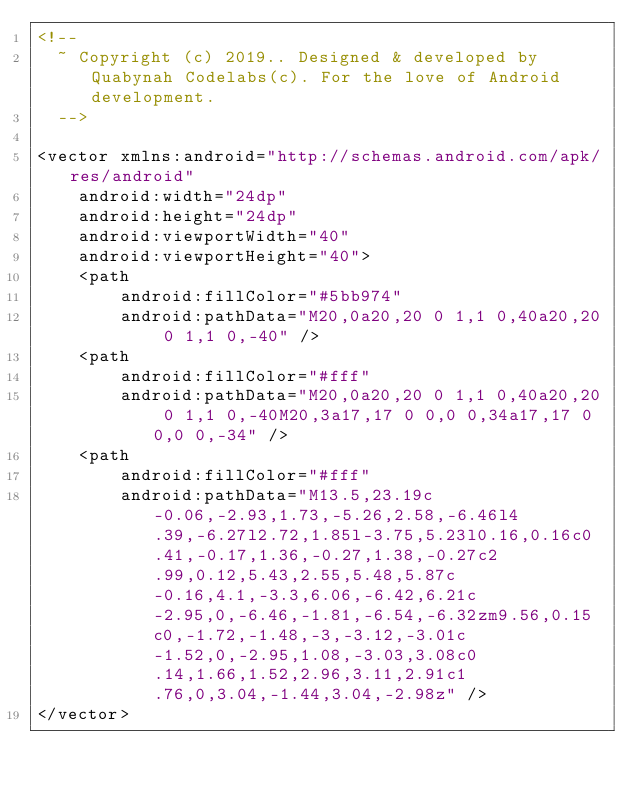Convert code to text. <code><loc_0><loc_0><loc_500><loc_500><_XML_><!--
  ~ Copyright (c) 2019.. Designed & developed by Quabynah Codelabs(c). For the love of Android development.
  -->

<vector xmlns:android="http://schemas.android.com/apk/res/android"
    android:width="24dp"
    android:height="24dp"
    android:viewportWidth="40"
    android:viewportHeight="40">
    <path
        android:fillColor="#5bb974"
        android:pathData="M20,0a20,20 0 1,1 0,40a20,20 0 1,1 0,-40" />
    <path
        android:fillColor="#fff"
        android:pathData="M20,0a20,20 0 1,1 0,40a20,20 0 1,1 0,-40M20,3a17,17 0 0,0 0,34a17,17 0 0,0 0,-34" />
    <path
        android:fillColor="#fff"
        android:pathData="M13.5,23.19c-0.06,-2.93,1.73,-5.26,2.58,-6.46l4.39,-6.27l2.72,1.85l-3.75,5.23l0.16,0.16c0.41,-0.17,1.36,-0.27,1.38,-0.27c2.99,0.12,5.43,2.55,5.48,5.87c-0.16,4.1,-3.3,6.06,-6.42,6.21c-2.95,0,-6.46,-1.81,-6.54,-6.32zm9.56,0.15c0,-1.72,-1.48,-3,-3.12,-3.01c-1.52,0,-2.95,1.08,-3.03,3.08c0.14,1.66,1.52,2.96,3.11,2.91c1.76,0,3.04,-1.44,3.04,-2.98z" />
</vector>
</code> 